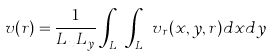<formula> <loc_0><loc_0><loc_500><loc_500>v ( r ) = \frac { 1 } { L _ { x } L _ { y } } \int _ { L _ { x } } \int _ { L _ { y } } v _ { r } ( x , y , r ) d x d y</formula> 